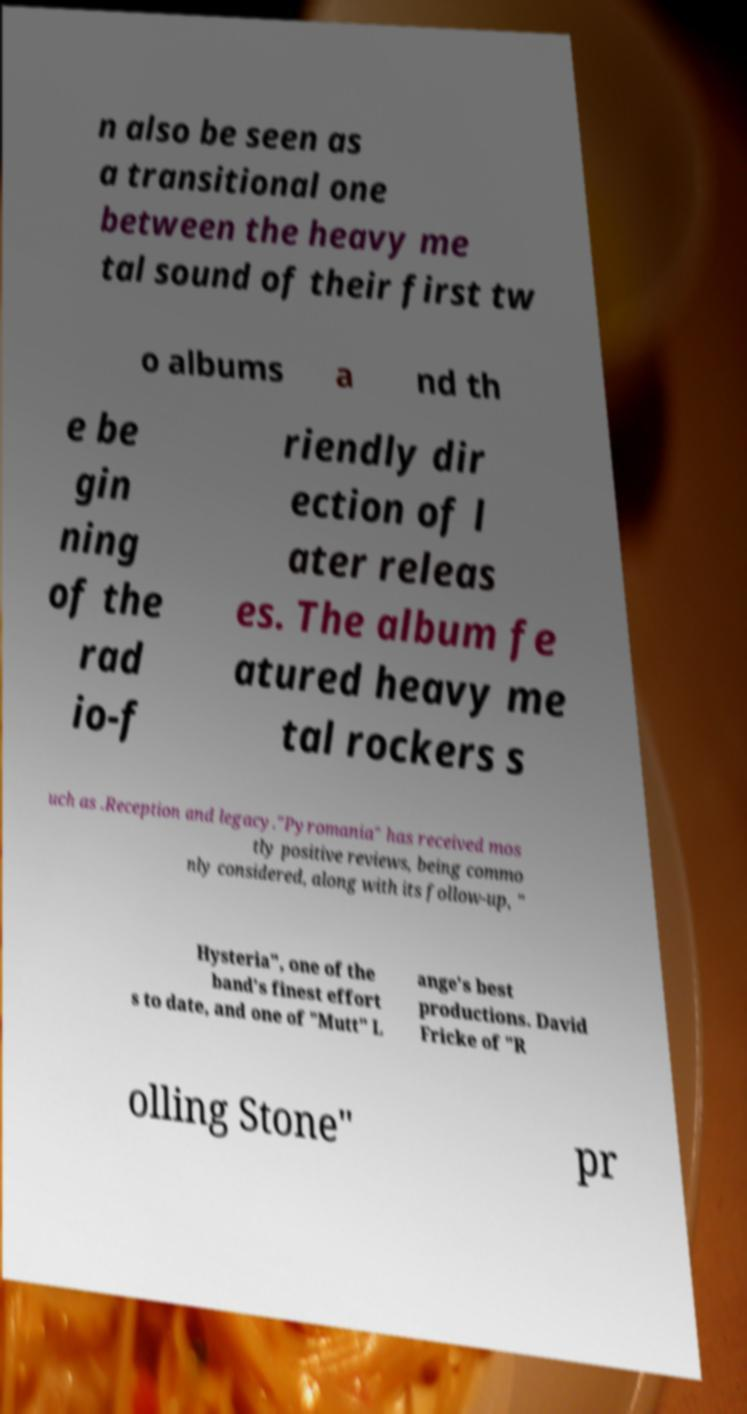Can you accurately transcribe the text from the provided image for me? n also be seen as a transitional one between the heavy me tal sound of their first tw o albums a nd th e be gin ning of the rad io-f riendly dir ection of l ater releas es. The album fe atured heavy me tal rockers s uch as .Reception and legacy."Pyromania" has received mos tly positive reviews, being commo nly considered, along with its follow-up, " Hysteria", one of the band's finest effort s to date, and one of "Mutt" L ange's best productions. David Fricke of "R olling Stone" pr 